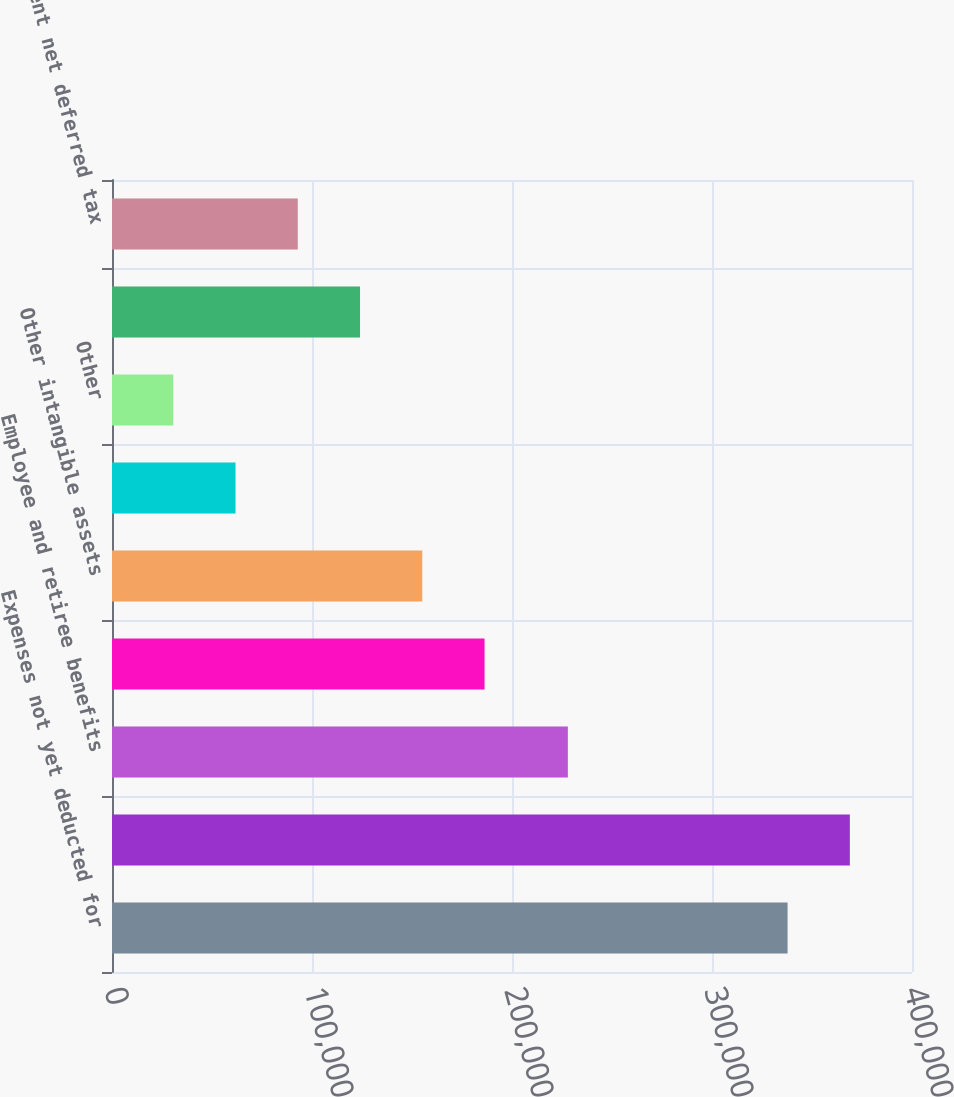<chart> <loc_0><loc_0><loc_500><loc_500><bar_chart><fcel>Expenses not yet deducted for<fcel>Pension liability not yet<fcel>Employee and retiree benefits<fcel>Inventory<fcel>Other intangible assets<fcel>Property plant and equipment<fcel>Other<fcel>Net deferred tax assets<fcel>Noncurrent net deferred tax<nl><fcel>337792<fcel>368918<fcel>227926<fcel>186272<fcel>155146<fcel>61767.3<fcel>30641<fcel>124020<fcel>92893.6<nl></chart> 